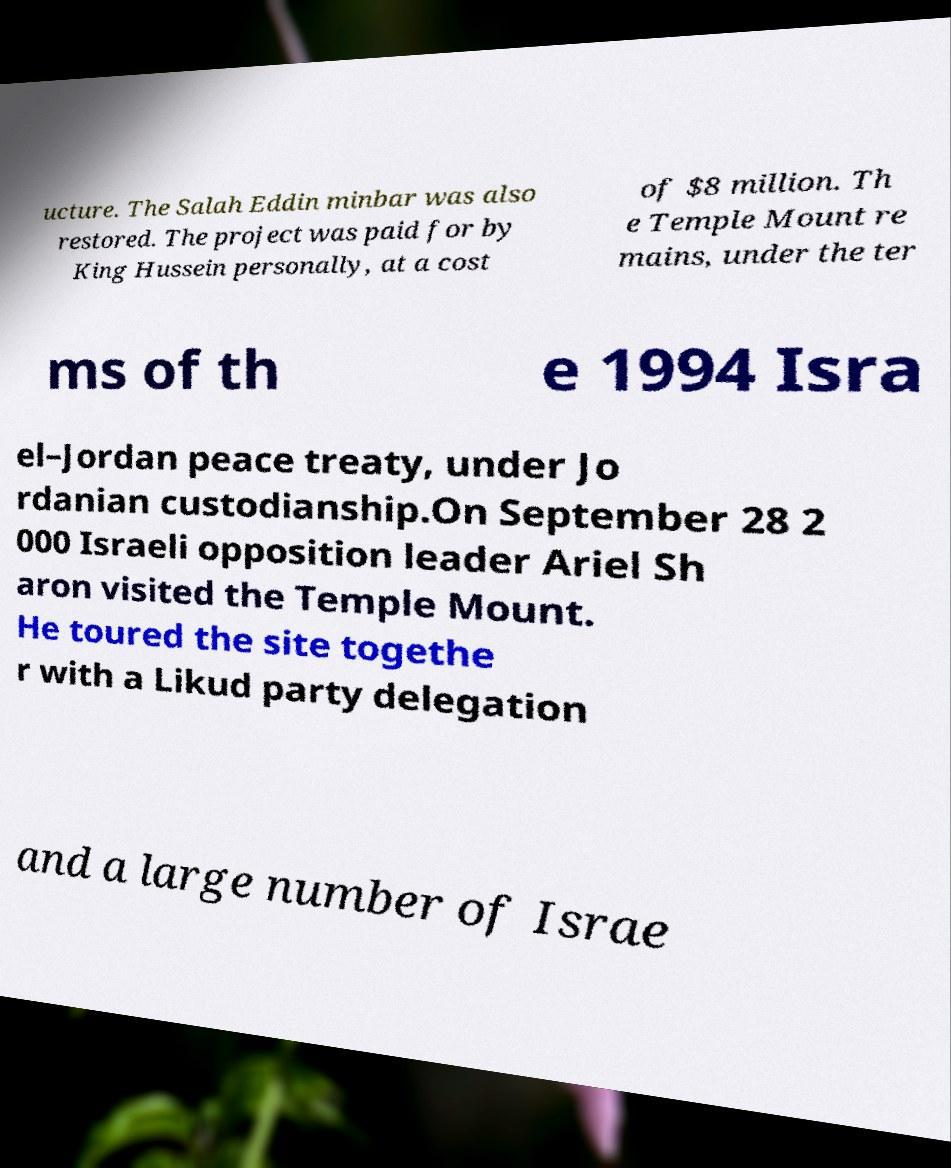What messages or text are displayed in this image? I need them in a readable, typed format. ucture. The Salah Eddin minbar was also restored. The project was paid for by King Hussein personally, at a cost of $8 million. Th e Temple Mount re mains, under the ter ms of th e 1994 Isra el–Jordan peace treaty, under Jo rdanian custodianship.On September 28 2 000 Israeli opposition leader Ariel Sh aron visited the Temple Mount. He toured the site togethe r with a Likud party delegation and a large number of Israe 